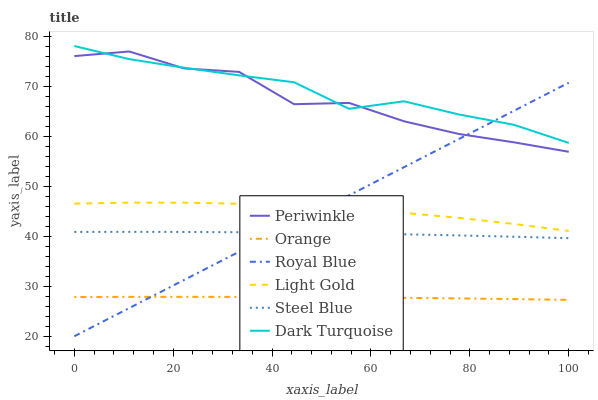Does Orange have the minimum area under the curve?
Answer yes or no. Yes. Does Dark Turquoise have the maximum area under the curve?
Answer yes or no. Yes. Does Steel Blue have the minimum area under the curve?
Answer yes or no. No. Does Steel Blue have the maximum area under the curve?
Answer yes or no. No. Is Royal Blue the smoothest?
Answer yes or no. Yes. Is Periwinkle the roughest?
Answer yes or no. Yes. Is Steel Blue the smoothest?
Answer yes or no. No. Is Steel Blue the roughest?
Answer yes or no. No. Does Royal Blue have the lowest value?
Answer yes or no. Yes. Does Steel Blue have the lowest value?
Answer yes or no. No. Does Dark Turquoise have the highest value?
Answer yes or no. Yes. Does Steel Blue have the highest value?
Answer yes or no. No. Is Light Gold less than Periwinkle?
Answer yes or no. Yes. Is Periwinkle greater than Light Gold?
Answer yes or no. Yes. Does Periwinkle intersect Dark Turquoise?
Answer yes or no. Yes. Is Periwinkle less than Dark Turquoise?
Answer yes or no. No. Is Periwinkle greater than Dark Turquoise?
Answer yes or no. No. Does Light Gold intersect Periwinkle?
Answer yes or no. No. 